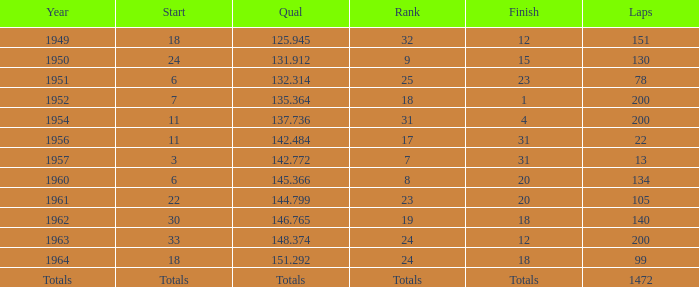Identify the position for 151 laps 32.0. Would you mind parsing the complete table? {'header': ['Year', 'Start', 'Qual', 'Rank', 'Finish', 'Laps'], 'rows': [['1949', '18', '125.945', '32', '12', '151'], ['1950', '24', '131.912', '9', '15', '130'], ['1951', '6', '132.314', '25', '23', '78'], ['1952', '7', '135.364', '18', '1', '200'], ['1954', '11', '137.736', '31', '4', '200'], ['1956', '11', '142.484', '17', '31', '22'], ['1957', '3', '142.772', '7', '31', '13'], ['1960', '6', '145.366', '8', '20', '134'], ['1961', '22', '144.799', '23', '20', '105'], ['1962', '30', '146.765', '19', '18', '140'], ['1963', '33', '148.374', '24', '12', '200'], ['1964', '18', '151.292', '24', '18', '99'], ['Totals', 'Totals', 'Totals', 'Totals', 'Totals', '1472']]} 